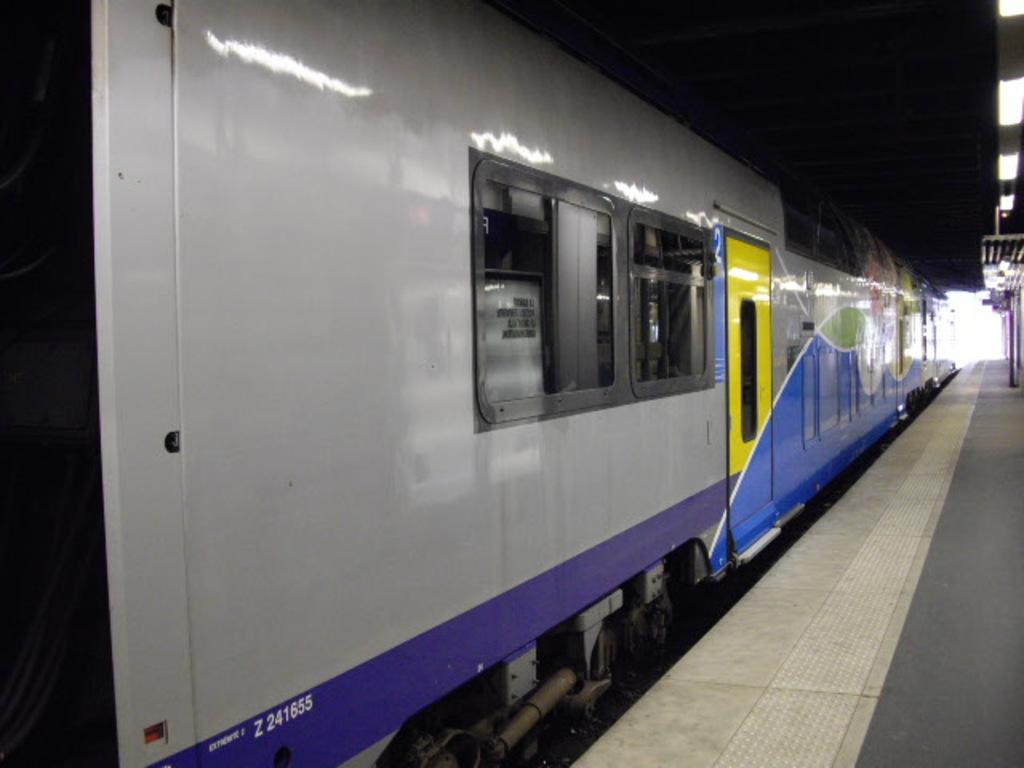What is the main subject of the image? The main subject of the image is a train. What features can be seen on the train? The train has windows and a door. Is there any text visible on the train? Yes, there is text written on the train. What is present on the right side of the image? There is a platform on the right side of the image. What can be observed about the platform? There are lights on the platform. What type of linen is being used to cover the train's windows in the image? There is no linen present in the image, and the train's windows are not covered. How does the train make you feel when you look at the image? The image does not convey any specific feelings, as it is an objective representation of a train and a platform. 